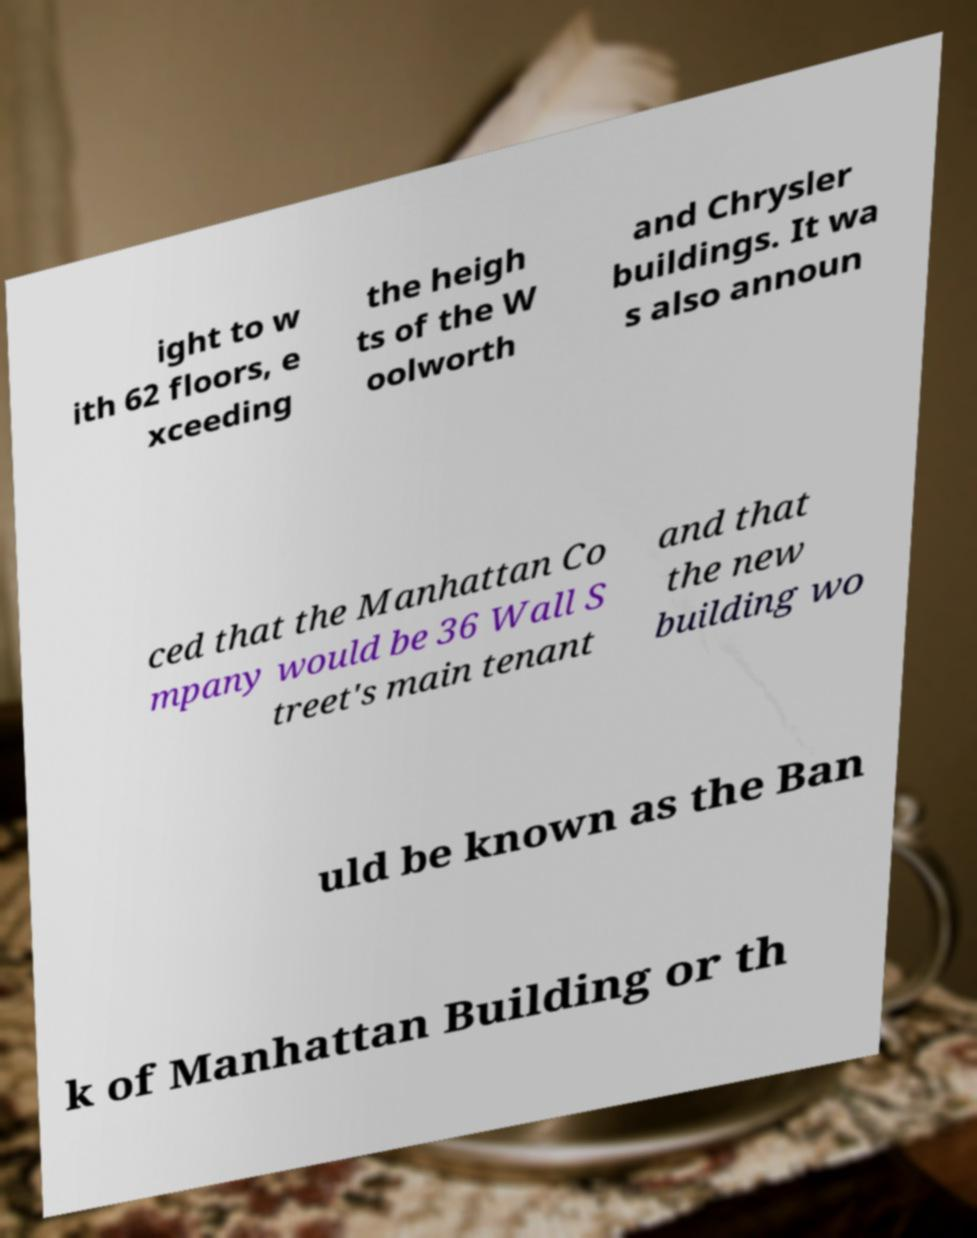Can you accurately transcribe the text from the provided image for me? ight to w ith 62 floors, e xceeding the heigh ts of the W oolworth and Chrysler buildings. It wa s also announ ced that the Manhattan Co mpany would be 36 Wall S treet's main tenant and that the new building wo uld be known as the Ban k of Manhattan Building or th 